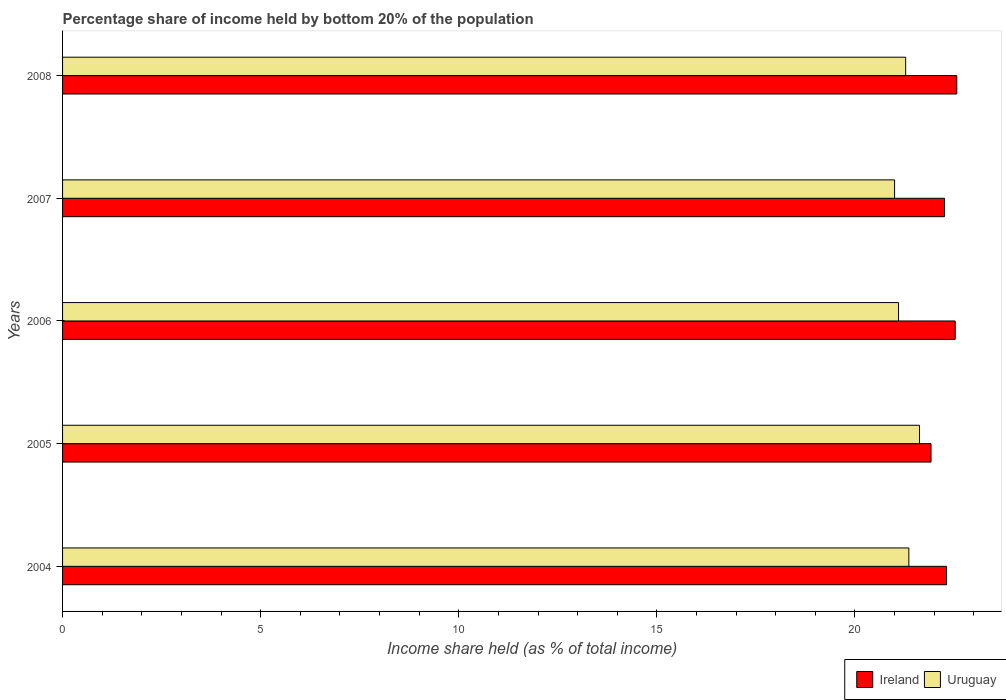How many different coloured bars are there?
Your answer should be very brief. 2. How many groups of bars are there?
Provide a short and direct response. 5. Are the number of bars per tick equal to the number of legend labels?
Ensure brevity in your answer.  Yes. Are the number of bars on each tick of the Y-axis equal?
Offer a terse response. Yes. How many bars are there on the 3rd tick from the top?
Your answer should be very brief. 2. How many bars are there on the 5th tick from the bottom?
Keep it short and to the point. 2. In how many cases, is the number of bars for a given year not equal to the number of legend labels?
Give a very brief answer. 0. What is the share of income held by bottom 20% of the population in Ireland in 2005?
Your answer should be very brief. 21.92. Across all years, what is the maximum share of income held by bottom 20% of the population in Uruguay?
Keep it short and to the point. 21.63. Across all years, what is the minimum share of income held by bottom 20% of the population in Ireland?
Keep it short and to the point. 21.92. In which year was the share of income held by bottom 20% of the population in Uruguay minimum?
Ensure brevity in your answer.  2007. What is the total share of income held by bottom 20% of the population in Ireland in the graph?
Make the answer very short. 111.59. What is the difference between the share of income held by bottom 20% of the population in Ireland in 2006 and that in 2007?
Your answer should be compact. 0.27. What is the difference between the share of income held by bottom 20% of the population in Uruguay in 2008 and the share of income held by bottom 20% of the population in Ireland in 2007?
Keep it short and to the point. -0.98. What is the average share of income held by bottom 20% of the population in Uruguay per year?
Provide a short and direct response. 21.27. In the year 2006, what is the difference between the share of income held by bottom 20% of the population in Uruguay and share of income held by bottom 20% of the population in Ireland?
Keep it short and to the point. -1.43. What is the ratio of the share of income held by bottom 20% of the population in Uruguay in 2004 to that in 2005?
Your answer should be very brief. 0.99. What is the difference between the highest and the second highest share of income held by bottom 20% of the population in Ireland?
Provide a short and direct response. 0.04. What is the difference between the highest and the lowest share of income held by bottom 20% of the population in Uruguay?
Ensure brevity in your answer.  0.63. In how many years, is the share of income held by bottom 20% of the population in Ireland greater than the average share of income held by bottom 20% of the population in Ireland taken over all years?
Ensure brevity in your answer.  2. Is the sum of the share of income held by bottom 20% of the population in Uruguay in 2004 and 2006 greater than the maximum share of income held by bottom 20% of the population in Ireland across all years?
Your answer should be very brief. Yes. What does the 2nd bar from the top in 2006 represents?
Keep it short and to the point. Ireland. What does the 1st bar from the bottom in 2005 represents?
Your response must be concise. Ireland. How many bars are there?
Your answer should be very brief. 10. Are all the bars in the graph horizontal?
Give a very brief answer. Yes. How many years are there in the graph?
Offer a very short reply. 5. Are the values on the major ticks of X-axis written in scientific E-notation?
Ensure brevity in your answer.  No. Does the graph contain grids?
Keep it short and to the point. No. Where does the legend appear in the graph?
Your answer should be very brief. Bottom right. How many legend labels are there?
Make the answer very short. 2. How are the legend labels stacked?
Your response must be concise. Horizontal. What is the title of the graph?
Your response must be concise. Percentage share of income held by bottom 20% of the population. What is the label or title of the X-axis?
Your answer should be very brief. Income share held (as % of total income). What is the Income share held (as % of total income) of Ireland in 2004?
Your answer should be compact. 22.31. What is the Income share held (as % of total income) in Uruguay in 2004?
Your response must be concise. 21.36. What is the Income share held (as % of total income) in Ireland in 2005?
Keep it short and to the point. 21.92. What is the Income share held (as % of total income) in Uruguay in 2005?
Give a very brief answer. 21.63. What is the Income share held (as % of total income) of Ireland in 2006?
Provide a succinct answer. 22.53. What is the Income share held (as % of total income) in Uruguay in 2006?
Keep it short and to the point. 21.1. What is the Income share held (as % of total income) in Ireland in 2007?
Offer a very short reply. 22.26. What is the Income share held (as % of total income) in Uruguay in 2007?
Ensure brevity in your answer.  21. What is the Income share held (as % of total income) of Ireland in 2008?
Offer a terse response. 22.57. What is the Income share held (as % of total income) in Uruguay in 2008?
Make the answer very short. 21.28. Across all years, what is the maximum Income share held (as % of total income) in Ireland?
Give a very brief answer. 22.57. Across all years, what is the maximum Income share held (as % of total income) in Uruguay?
Your answer should be very brief. 21.63. Across all years, what is the minimum Income share held (as % of total income) of Ireland?
Your response must be concise. 21.92. What is the total Income share held (as % of total income) of Ireland in the graph?
Offer a terse response. 111.59. What is the total Income share held (as % of total income) of Uruguay in the graph?
Offer a very short reply. 106.37. What is the difference between the Income share held (as % of total income) in Ireland in 2004 and that in 2005?
Keep it short and to the point. 0.39. What is the difference between the Income share held (as % of total income) in Uruguay in 2004 and that in 2005?
Give a very brief answer. -0.27. What is the difference between the Income share held (as % of total income) in Ireland in 2004 and that in 2006?
Offer a terse response. -0.22. What is the difference between the Income share held (as % of total income) in Uruguay in 2004 and that in 2006?
Ensure brevity in your answer.  0.26. What is the difference between the Income share held (as % of total income) in Ireland in 2004 and that in 2007?
Make the answer very short. 0.05. What is the difference between the Income share held (as % of total income) in Uruguay in 2004 and that in 2007?
Your response must be concise. 0.36. What is the difference between the Income share held (as % of total income) in Ireland in 2004 and that in 2008?
Offer a terse response. -0.26. What is the difference between the Income share held (as % of total income) in Ireland in 2005 and that in 2006?
Provide a succinct answer. -0.61. What is the difference between the Income share held (as % of total income) of Uruguay in 2005 and that in 2006?
Your answer should be very brief. 0.53. What is the difference between the Income share held (as % of total income) in Ireland in 2005 and that in 2007?
Offer a very short reply. -0.34. What is the difference between the Income share held (as % of total income) in Uruguay in 2005 and that in 2007?
Keep it short and to the point. 0.63. What is the difference between the Income share held (as % of total income) in Ireland in 2005 and that in 2008?
Your response must be concise. -0.65. What is the difference between the Income share held (as % of total income) of Uruguay in 2005 and that in 2008?
Your answer should be compact. 0.35. What is the difference between the Income share held (as % of total income) in Ireland in 2006 and that in 2007?
Your response must be concise. 0.27. What is the difference between the Income share held (as % of total income) of Ireland in 2006 and that in 2008?
Ensure brevity in your answer.  -0.04. What is the difference between the Income share held (as % of total income) of Uruguay in 2006 and that in 2008?
Give a very brief answer. -0.18. What is the difference between the Income share held (as % of total income) of Ireland in 2007 and that in 2008?
Provide a short and direct response. -0.31. What is the difference between the Income share held (as % of total income) of Uruguay in 2007 and that in 2008?
Ensure brevity in your answer.  -0.28. What is the difference between the Income share held (as % of total income) in Ireland in 2004 and the Income share held (as % of total income) in Uruguay in 2005?
Keep it short and to the point. 0.68. What is the difference between the Income share held (as % of total income) in Ireland in 2004 and the Income share held (as % of total income) in Uruguay in 2006?
Provide a short and direct response. 1.21. What is the difference between the Income share held (as % of total income) of Ireland in 2004 and the Income share held (as % of total income) of Uruguay in 2007?
Offer a very short reply. 1.31. What is the difference between the Income share held (as % of total income) in Ireland in 2005 and the Income share held (as % of total income) in Uruguay in 2006?
Provide a succinct answer. 0.82. What is the difference between the Income share held (as % of total income) of Ireland in 2005 and the Income share held (as % of total income) of Uruguay in 2007?
Keep it short and to the point. 0.92. What is the difference between the Income share held (as % of total income) in Ireland in 2005 and the Income share held (as % of total income) in Uruguay in 2008?
Give a very brief answer. 0.64. What is the difference between the Income share held (as % of total income) in Ireland in 2006 and the Income share held (as % of total income) in Uruguay in 2007?
Keep it short and to the point. 1.53. What is the average Income share held (as % of total income) of Ireland per year?
Offer a terse response. 22.32. What is the average Income share held (as % of total income) of Uruguay per year?
Ensure brevity in your answer.  21.27. In the year 2004, what is the difference between the Income share held (as % of total income) in Ireland and Income share held (as % of total income) in Uruguay?
Provide a short and direct response. 0.95. In the year 2005, what is the difference between the Income share held (as % of total income) in Ireland and Income share held (as % of total income) in Uruguay?
Provide a succinct answer. 0.29. In the year 2006, what is the difference between the Income share held (as % of total income) of Ireland and Income share held (as % of total income) of Uruguay?
Provide a succinct answer. 1.43. In the year 2007, what is the difference between the Income share held (as % of total income) in Ireland and Income share held (as % of total income) in Uruguay?
Keep it short and to the point. 1.26. In the year 2008, what is the difference between the Income share held (as % of total income) in Ireland and Income share held (as % of total income) in Uruguay?
Provide a short and direct response. 1.29. What is the ratio of the Income share held (as % of total income) of Ireland in 2004 to that in 2005?
Your response must be concise. 1.02. What is the ratio of the Income share held (as % of total income) of Uruguay in 2004 to that in 2005?
Offer a terse response. 0.99. What is the ratio of the Income share held (as % of total income) in Ireland in 2004 to that in 2006?
Keep it short and to the point. 0.99. What is the ratio of the Income share held (as % of total income) of Uruguay in 2004 to that in 2006?
Your answer should be compact. 1.01. What is the ratio of the Income share held (as % of total income) in Ireland in 2004 to that in 2007?
Make the answer very short. 1. What is the ratio of the Income share held (as % of total income) in Uruguay in 2004 to that in 2007?
Offer a very short reply. 1.02. What is the ratio of the Income share held (as % of total income) in Ireland in 2005 to that in 2006?
Your answer should be compact. 0.97. What is the ratio of the Income share held (as % of total income) in Uruguay in 2005 to that in 2006?
Offer a very short reply. 1.03. What is the ratio of the Income share held (as % of total income) of Ireland in 2005 to that in 2007?
Give a very brief answer. 0.98. What is the ratio of the Income share held (as % of total income) in Ireland in 2005 to that in 2008?
Your answer should be very brief. 0.97. What is the ratio of the Income share held (as % of total income) in Uruguay in 2005 to that in 2008?
Offer a very short reply. 1.02. What is the ratio of the Income share held (as % of total income) in Ireland in 2006 to that in 2007?
Make the answer very short. 1.01. What is the ratio of the Income share held (as % of total income) of Ireland in 2007 to that in 2008?
Keep it short and to the point. 0.99. What is the ratio of the Income share held (as % of total income) in Uruguay in 2007 to that in 2008?
Make the answer very short. 0.99. What is the difference between the highest and the second highest Income share held (as % of total income) of Uruguay?
Give a very brief answer. 0.27. What is the difference between the highest and the lowest Income share held (as % of total income) in Ireland?
Offer a terse response. 0.65. What is the difference between the highest and the lowest Income share held (as % of total income) in Uruguay?
Your answer should be very brief. 0.63. 